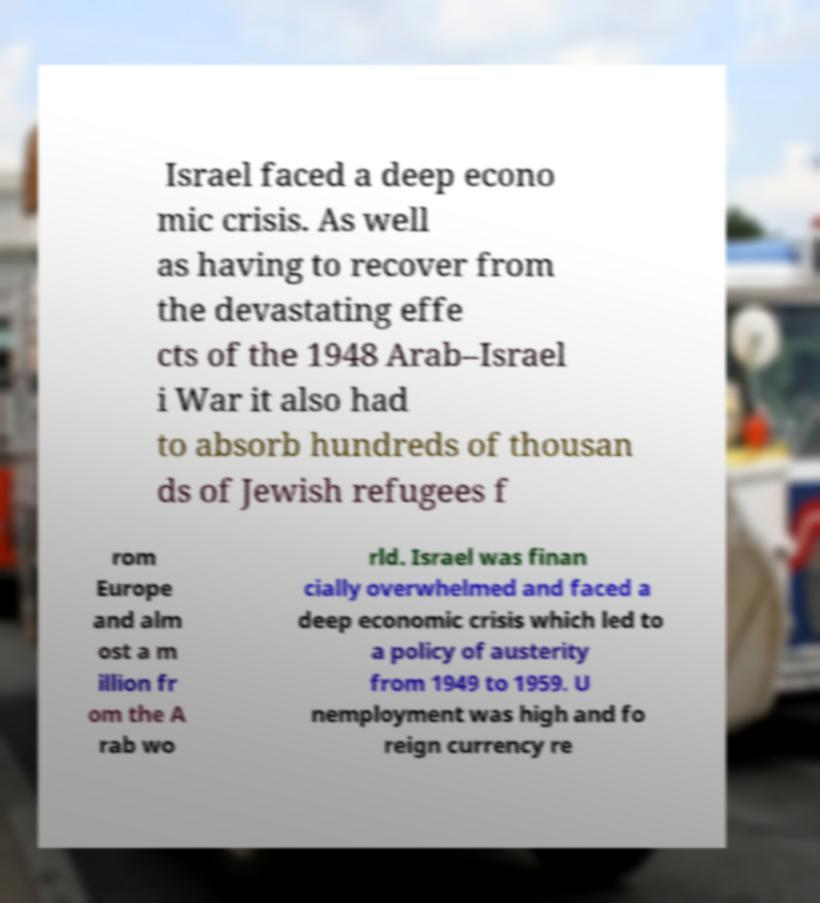Could you assist in decoding the text presented in this image and type it out clearly? Israel faced a deep econo mic crisis. As well as having to recover from the devastating effe cts of the 1948 Arab–Israel i War it also had to absorb hundreds of thousan ds of Jewish refugees f rom Europe and alm ost a m illion fr om the A rab wo rld. Israel was finan cially overwhelmed and faced a deep economic crisis which led to a policy of austerity from 1949 to 1959. U nemployment was high and fo reign currency re 